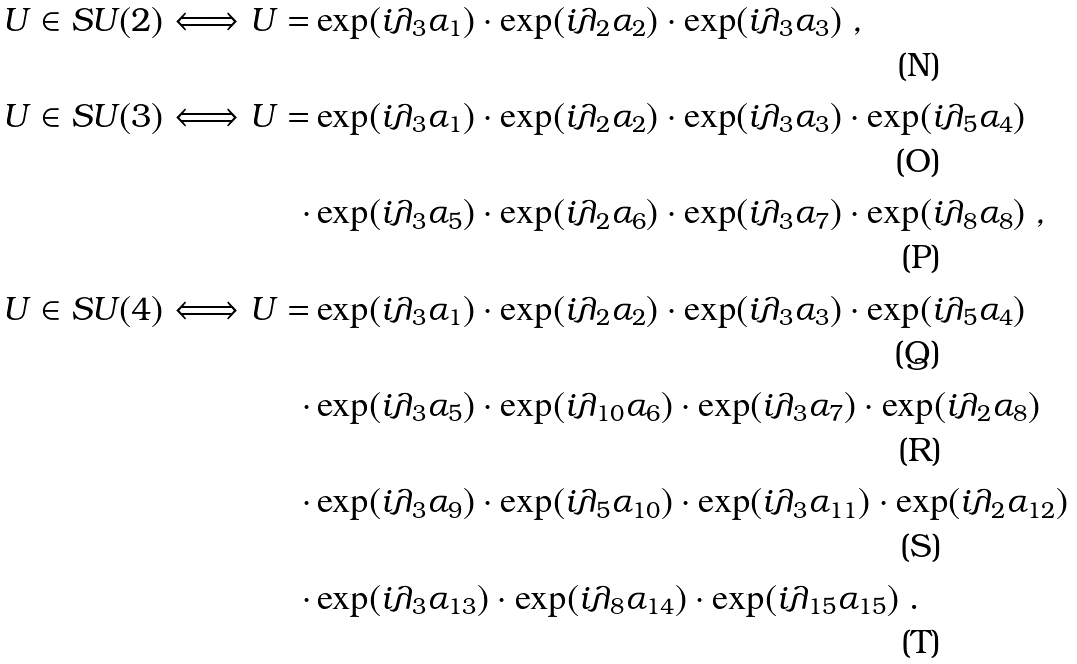<formula> <loc_0><loc_0><loc_500><loc_500>U \in S U ( 2 ) \Longleftrightarrow U = & \exp ( i \lambda _ { 3 } \alpha _ { 1 } ) \cdot \exp ( i \lambda _ { 2 } \alpha _ { 2 } ) \cdot \exp ( i \lambda _ { 3 } \alpha _ { 3 } ) \ , \\ U \in S U ( 3 ) \Longleftrightarrow U = & \exp ( i \lambda _ { 3 } \alpha _ { 1 } ) \cdot \exp ( i \lambda _ { 2 } \alpha _ { 2 } ) \cdot \exp ( i \lambda _ { 3 } \alpha _ { 3 } ) \cdot \exp ( i \lambda _ { 5 } \alpha _ { 4 } ) \\ \cdot & \exp ( i \lambda _ { 3 } \alpha _ { 5 } ) \cdot \exp ( i \lambda _ { 2 } \alpha _ { 6 } ) \cdot \exp ( i \lambda _ { 3 } \alpha _ { 7 } ) \cdot \exp ( i \lambda _ { 8 } \alpha _ { 8 } ) \ , \\ U \in S U ( 4 ) \Longleftrightarrow U = & \exp ( i \lambda _ { 3 } \alpha _ { 1 } ) \cdot \exp ( i \lambda _ { 2 } \alpha _ { 2 } ) \cdot \exp ( i \lambda _ { 3 } \alpha _ { 3 } ) \cdot \exp ( i \lambda _ { 5 } \alpha _ { 4 } ) \\ \cdot & \exp ( i \lambda _ { 3 } \alpha _ { 5 } ) \cdot \exp ( i \lambda _ { 1 0 } \alpha _ { 6 } ) \cdot \exp ( i \lambda _ { 3 } \alpha _ { 7 } ) \cdot \exp ( i \lambda _ { 2 } \alpha _ { 8 } ) \\ \cdot & \exp ( i \lambda _ { 3 } \alpha _ { 9 } ) \cdot \exp ( i \lambda _ { 5 } \alpha _ { 1 0 } ) \cdot \exp ( i \lambda _ { 3 } \alpha _ { 1 1 } ) \cdot \exp ( i \lambda _ { 2 } \alpha _ { 1 2 } ) \\ \cdot & \exp ( i \lambda _ { 3 } \alpha _ { 1 3 } ) \cdot \exp ( i \lambda _ { 8 } \alpha _ { 1 4 } ) \cdot \exp ( i \lambda _ { 1 5 } \alpha _ { 1 5 } ) \ .</formula> 